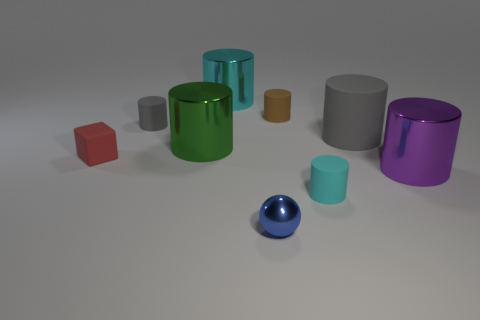Subtract all small cyan cylinders. How many cylinders are left? 6 Subtract all yellow cubes. How many gray cylinders are left? 2 Subtract all gray cylinders. How many cylinders are left? 5 Add 1 small blue balls. How many objects exist? 10 Subtract 4 cylinders. How many cylinders are left? 3 Subtract all gray cylinders. Subtract all blue spheres. How many cylinders are left? 5 Subtract all green cylinders. Subtract all large green cylinders. How many objects are left? 7 Add 6 cyan shiny cylinders. How many cyan shiny cylinders are left? 7 Add 8 cyan matte spheres. How many cyan matte spheres exist? 8 Subtract 0 gray spheres. How many objects are left? 9 